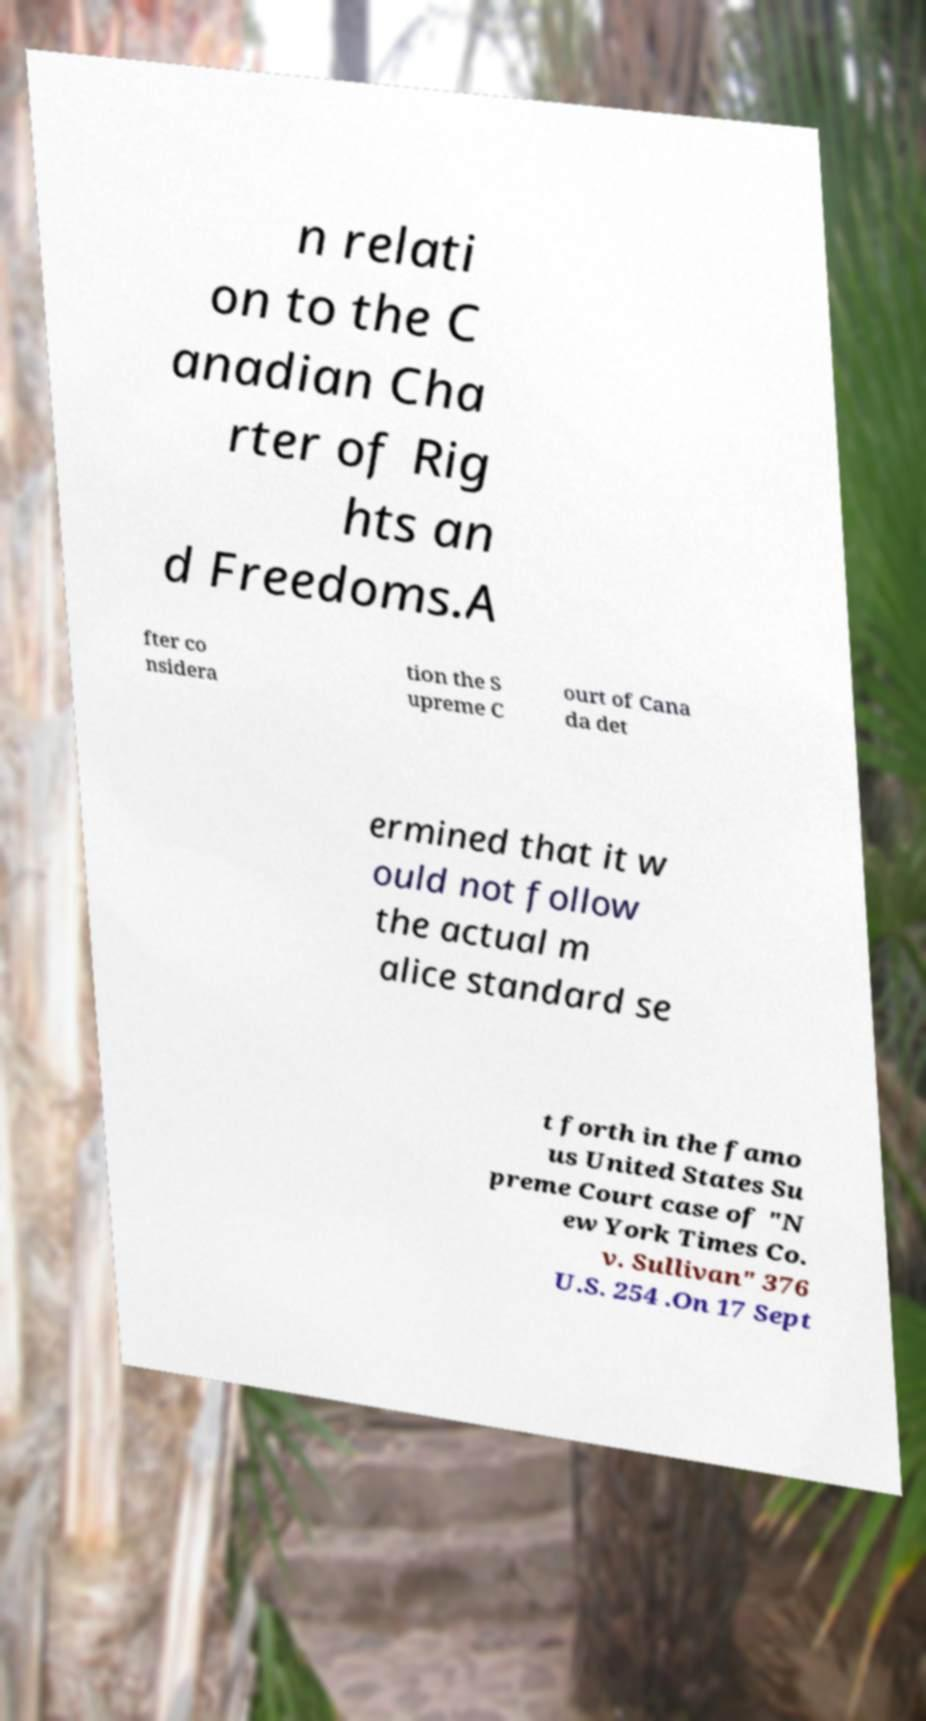Can you read and provide the text displayed in the image?This photo seems to have some interesting text. Can you extract and type it out for me? n relati on to the C anadian Cha rter of Rig hts an d Freedoms.A fter co nsidera tion the S upreme C ourt of Cana da det ermined that it w ould not follow the actual m alice standard se t forth in the famo us United States Su preme Court case of "N ew York Times Co. v. Sullivan" 376 U.S. 254 .On 17 Sept 